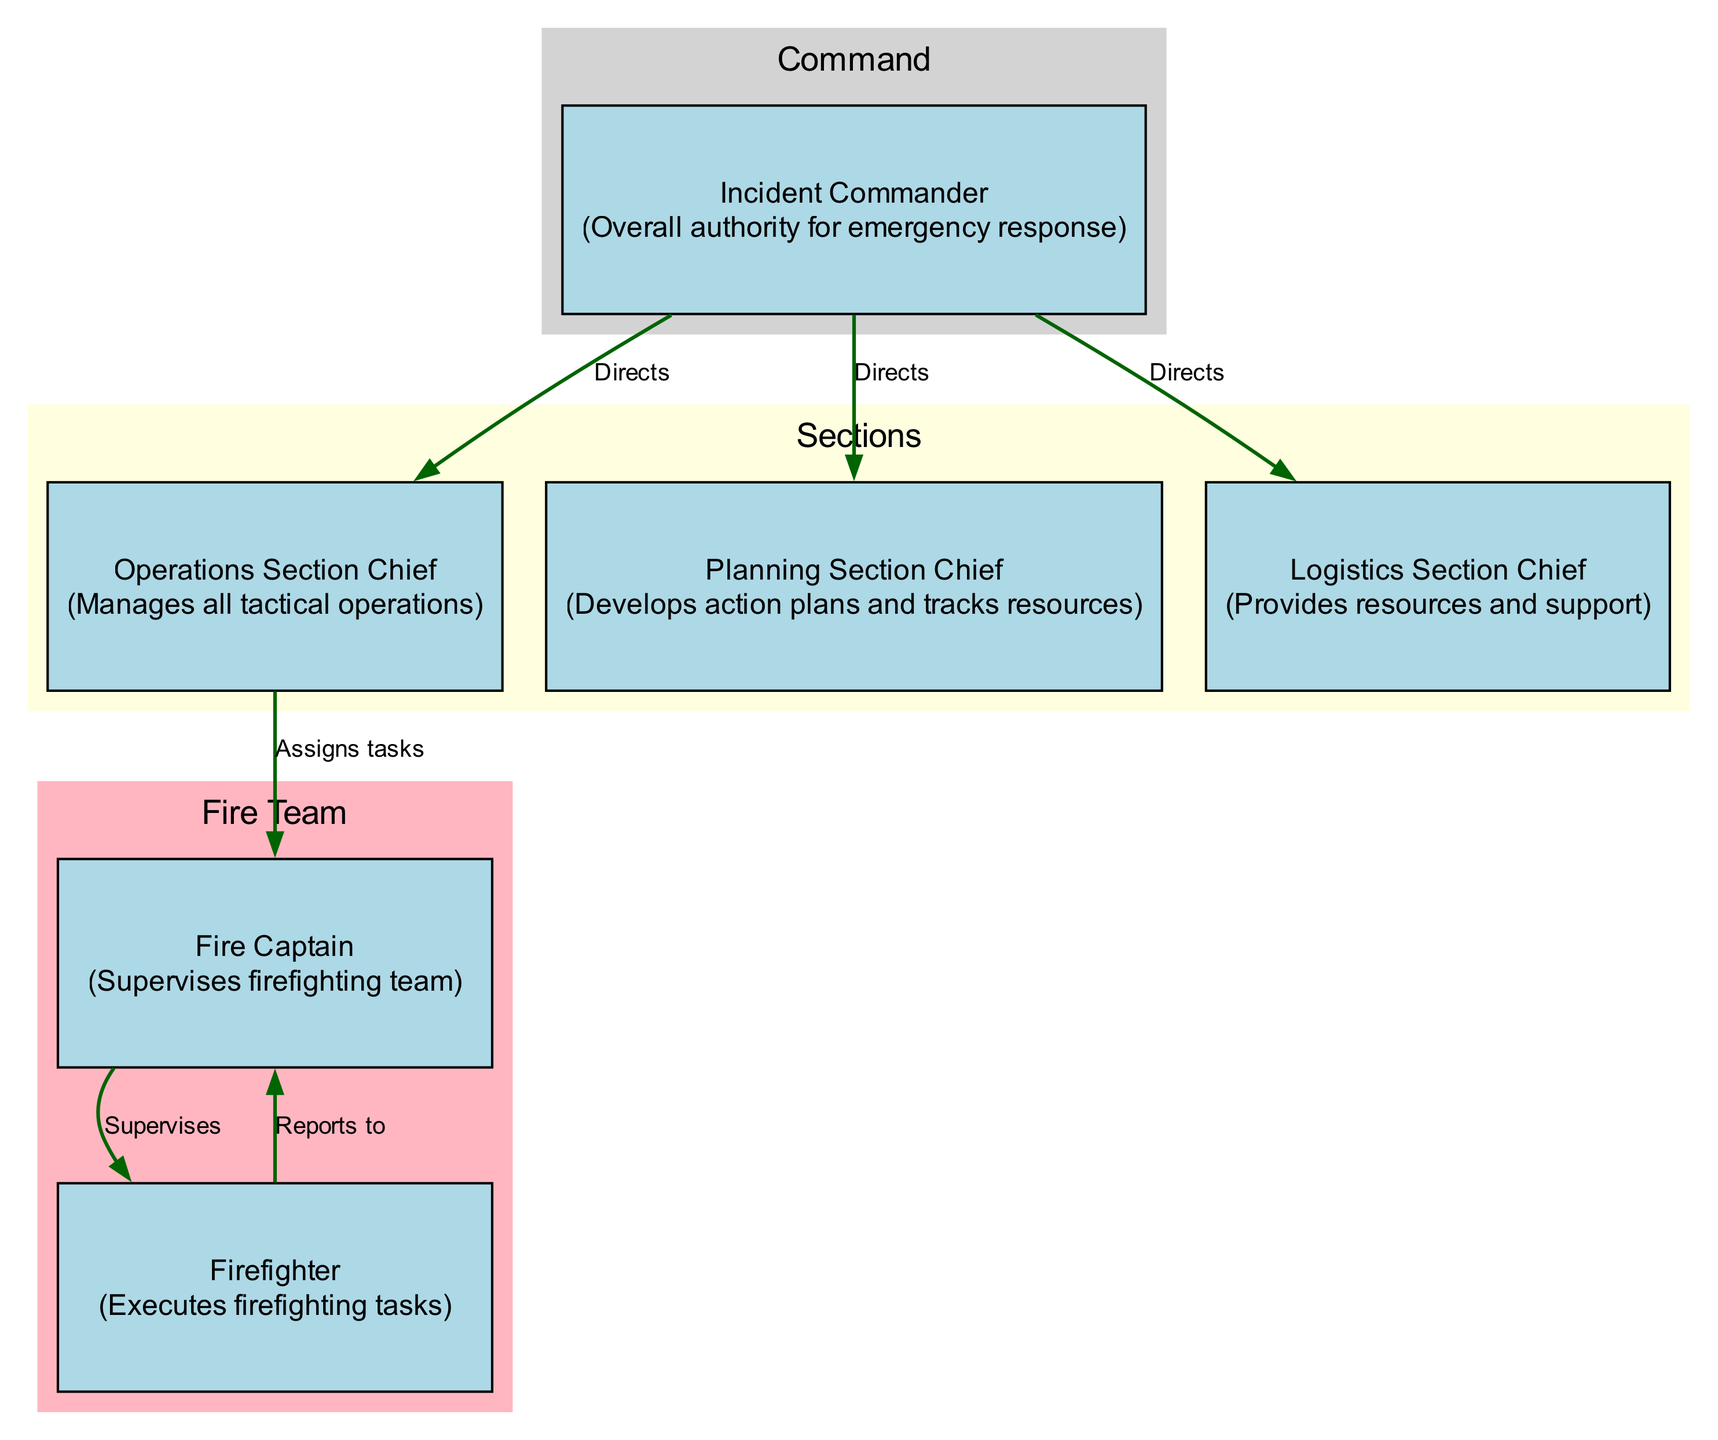What is the label of the topmost node in the diagram? The topmost node is labeled "Incident Commander." It is indicated as the highest authority in the structure, and visually positioned at the top of the diagram.
Answer: Incident Commander How many sections are in the incident command system hierarchy? The diagram contains three main sections: Command, Sections, and Fire Team, as indicated by the clusters grouping related nodes together.
Answer: Three Who does the Operations Section Chief directly report to? The Operations Section Chief directly reports to the Incident Commander, as shown by the directed edge labeled "Directs" connecting these two nodes.
Answer: Incident Commander What is the main responsibility of the Planning Section Chief? The Planning Section Chief is responsible for developing action plans and tracking resources, as denoted in the node description associated with that position.
Answer: Develops action plans and tracks resources What is the relationship between the Fire Captain and Firefighter? The relationship is one of supervision, as the Fire Captain supervises the Firefighter, indicated by the directed edge labeled "Supervises" from Fire Captain to Firefighter.
Answer: Supervises How many nodes are there in the Fire Team section? In the Fire Team section, there are two nodes: Fire Captain and Firefighter. This is visually confirmed by counting the nodes within the highlighted cluster for Fire Team.
Answer: Two Which node manages all tactical operations? The node that manages all tactical operations is the Operations Section Chief, as explicitly described in the information provided about that node.
Answer: Operations Section Chief Who assigns tasks to the Fire Captain? The Operations Section Chief assigns tasks to the Fire Captain, as illustrated by the directed edge labeled "Assigns tasks" connecting these two nodes.
Answer: Operations Section Chief What color represents the Sections in the diagram? The color that represents the Sections in the diagram is light yellow, as indicated by the cluster's color attribute assigned to that specific group of nodes.
Answer: Light yellow 